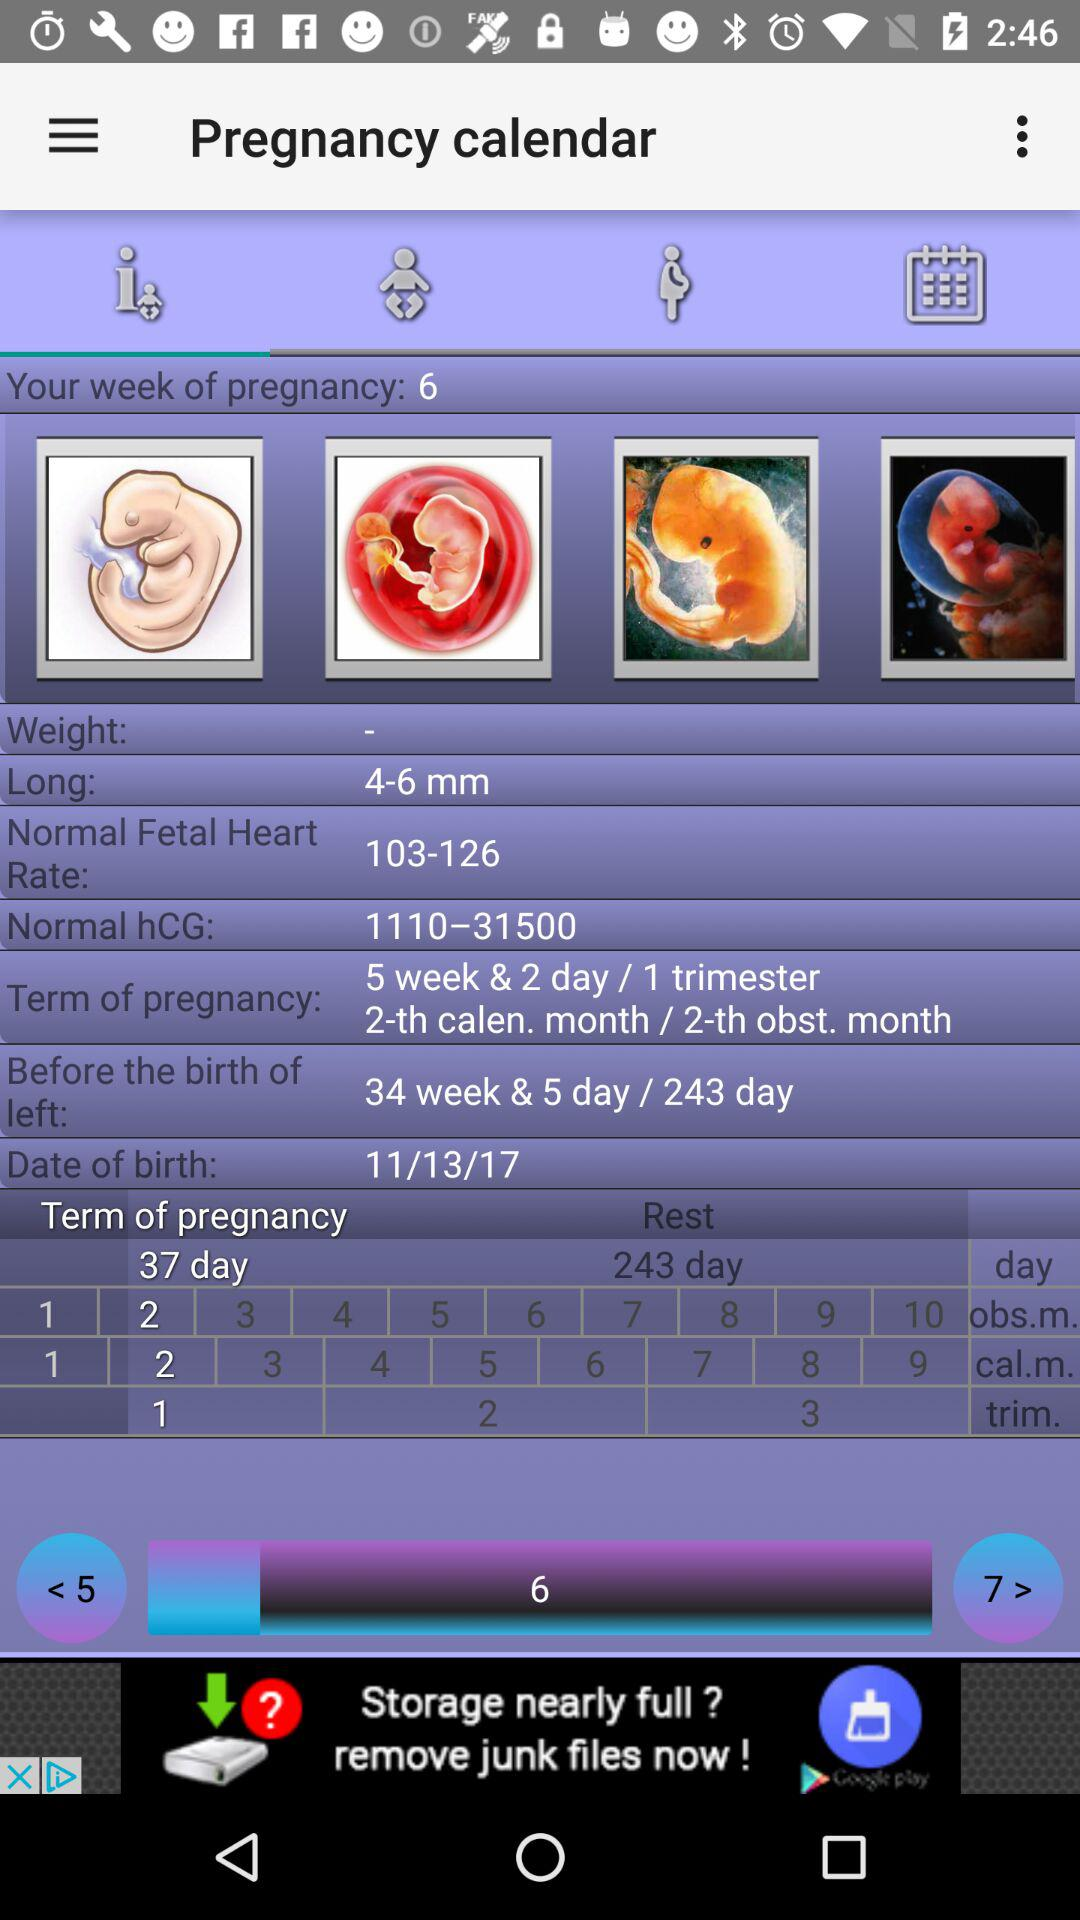What is your week of pregnancy? Your week of pregnancy is 6. 